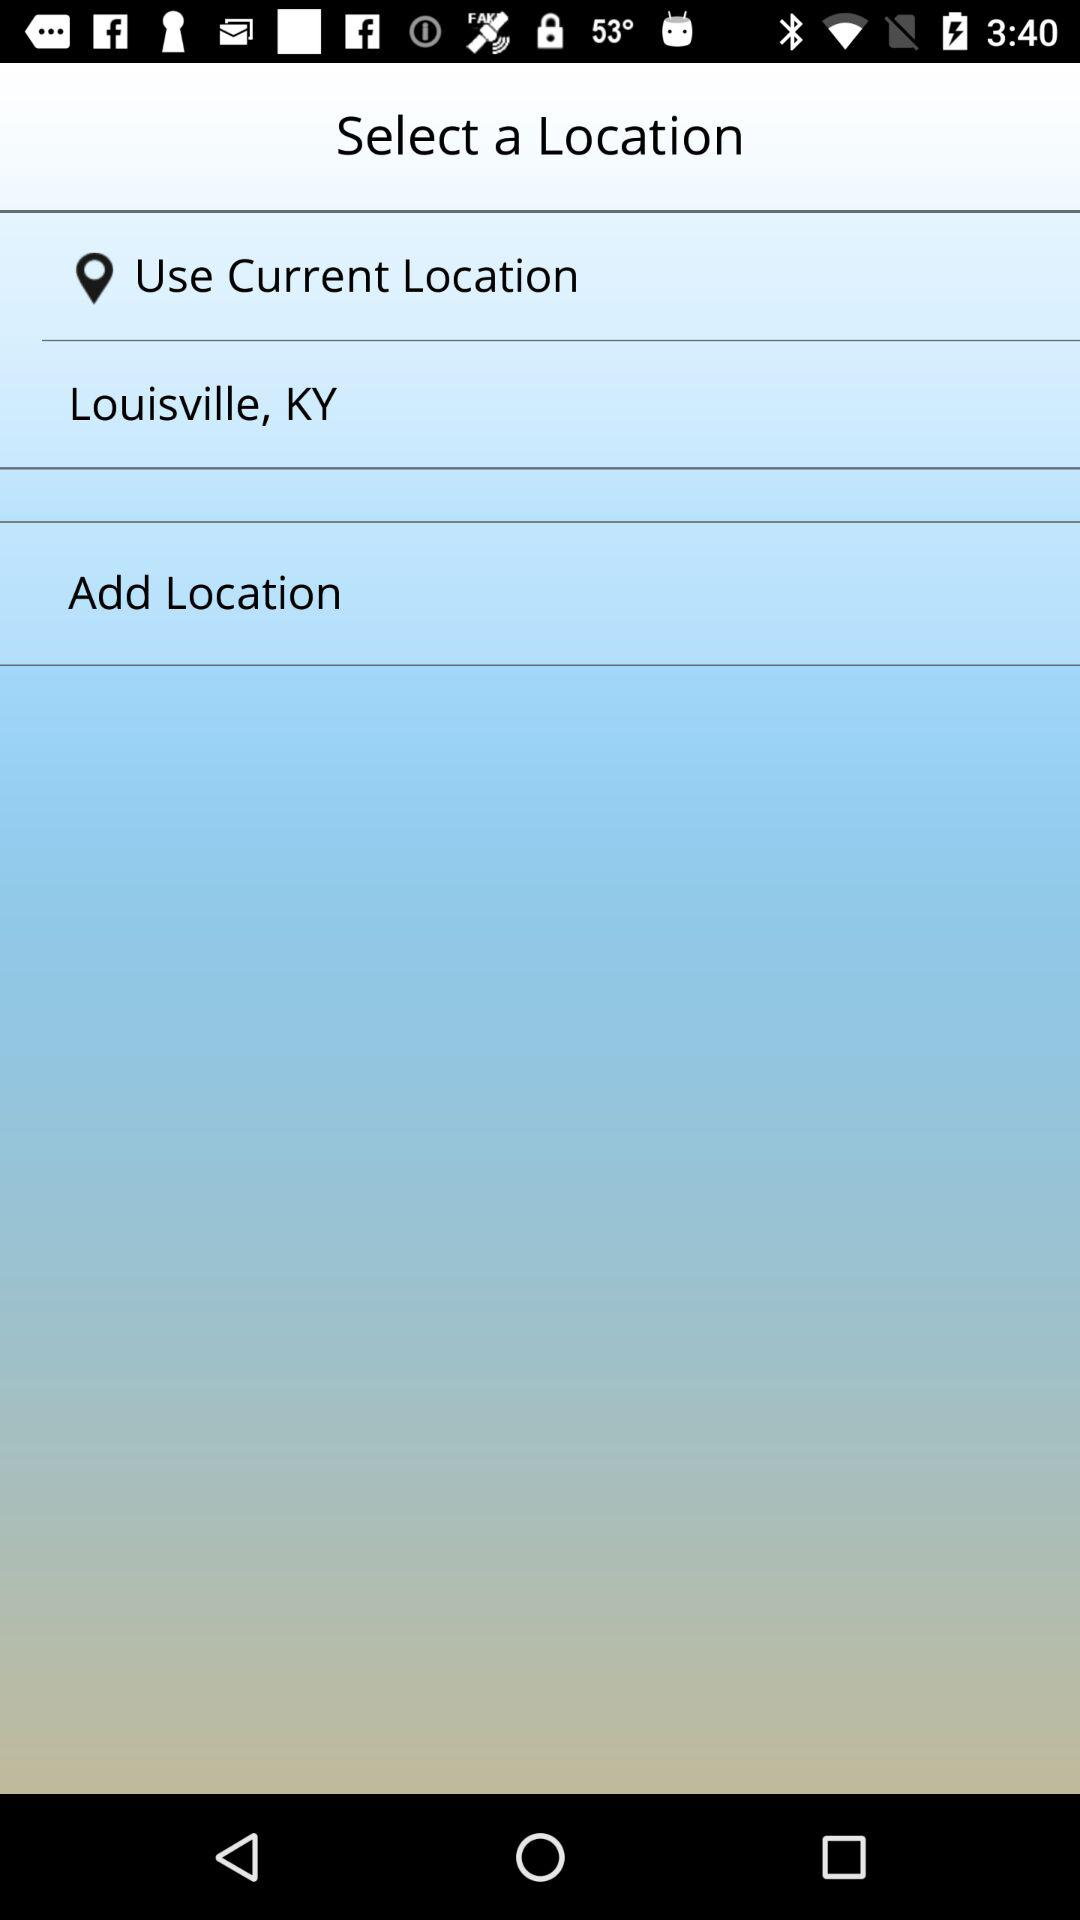What is the current location? The current location is Louisville, KY. 